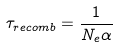<formula> <loc_0><loc_0><loc_500><loc_500>\tau _ { r e c o m b } = \frac { 1 } { N _ { e } \alpha }</formula> 